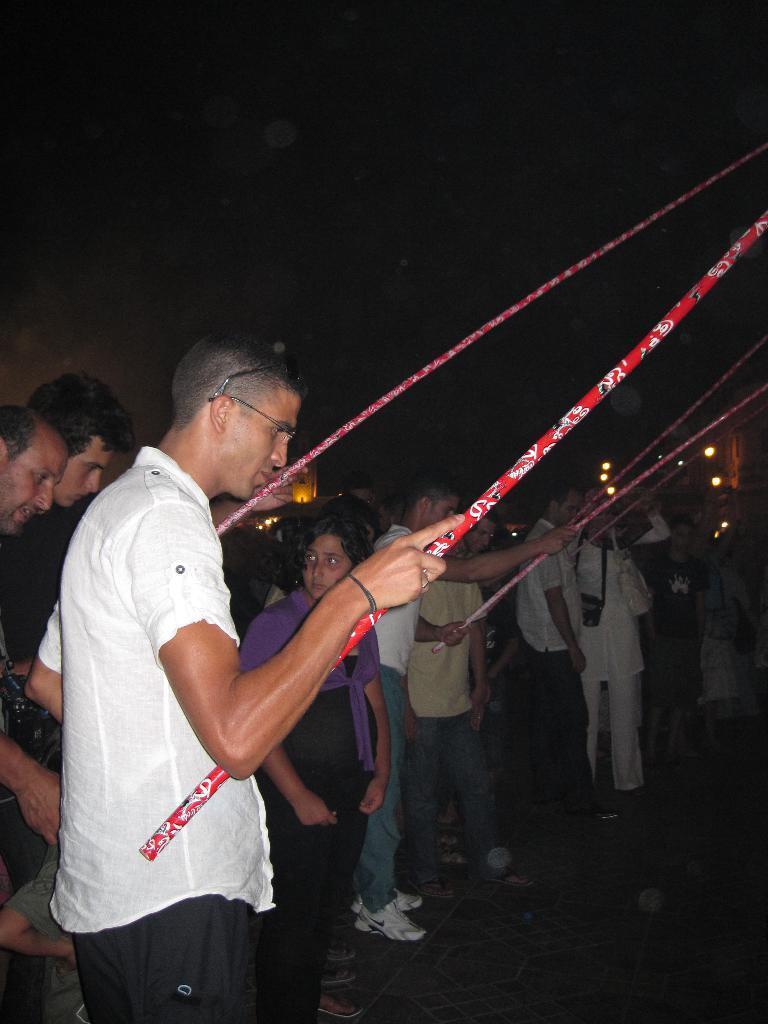Describe this image in one or two sentences. In this image there are a group of people standing on the ground in which few of them are holding big red sticks. 